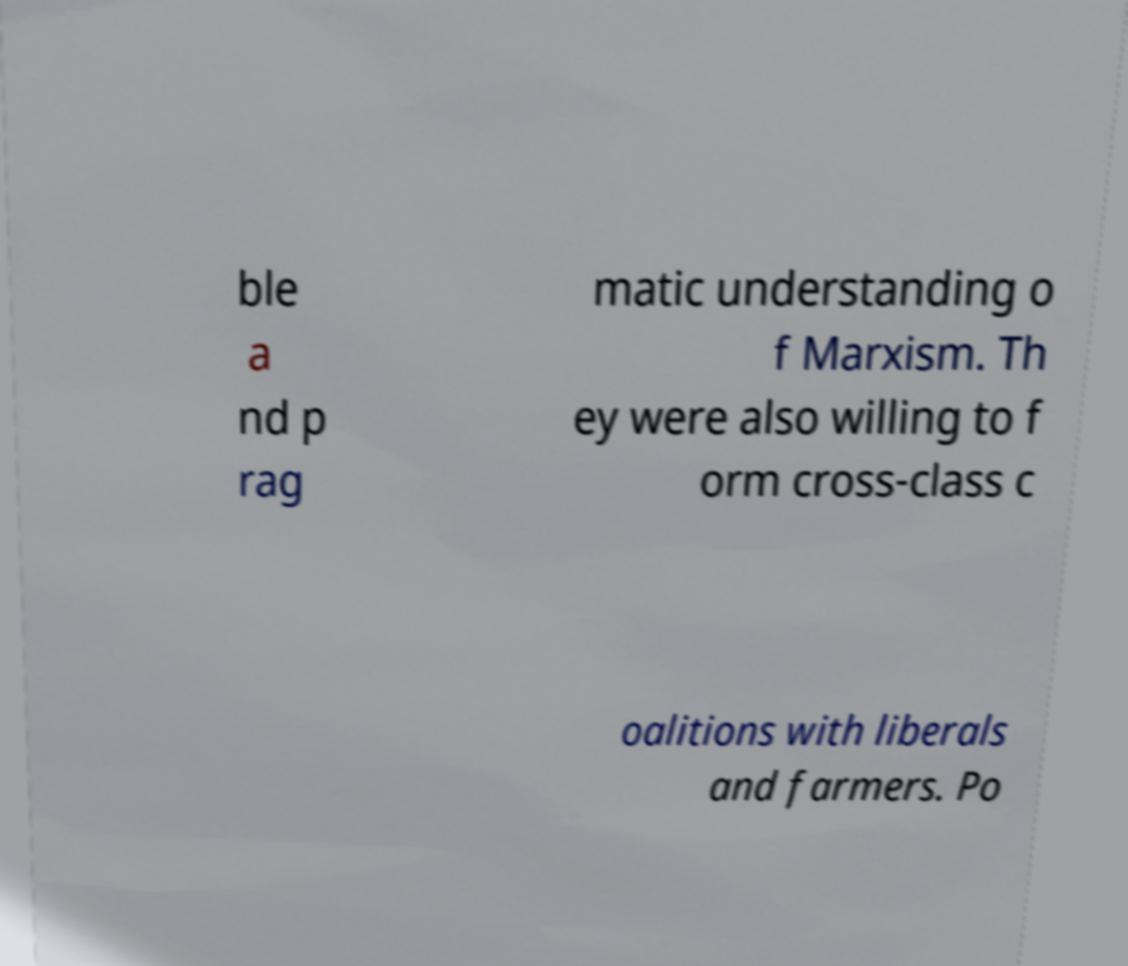Could you assist in decoding the text presented in this image and type it out clearly? ble a nd p rag matic understanding o f Marxism. Th ey were also willing to f orm cross-class c oalitions with liberals and farmers. Po 